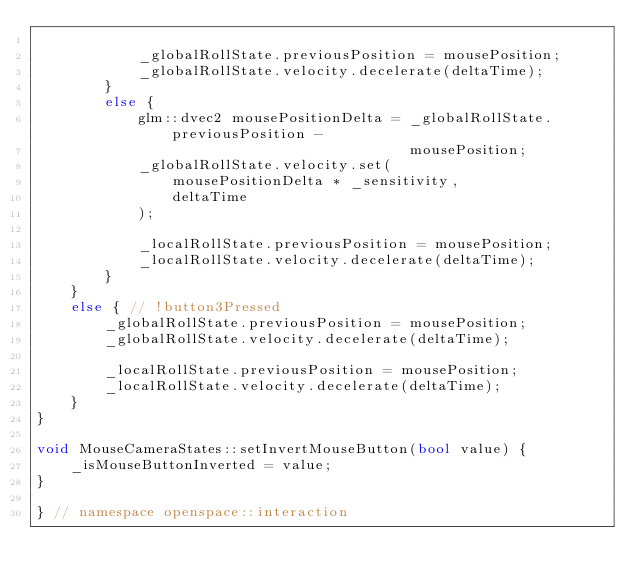Convert code to text. <code><loc_0><loc_0><loc_500><loc_500><_C++_>
            _globalRollState.previousPosition = mousePosition;
            _globalRollState.velocity.decelerate(deltaTime);
        }
        else {
            glm::dvec2 mousePositionDelta = _globalRollState.previousPosition -
                                            mousePosition;
            _globalRollState.velocity.set(
                mousePositionDelta * _sensitivity,
                deltaTime
            );

            _localRollState.previousPosition = mousePosition;
            _localRollState.velocity.decelerate(deltaTime);
        }
    }
    else { // !button3Pressed
        _globalRollState.previousPosition = mousePosition;
        _globalRollState.velocity.decelerate(deltaTime);

        _localRollState.previousPosition = mousePosition;
        _localRollState.velocity.decelerate(deltaTime);
    }
}

void MouseCameraStates::setInvertMouseButton(bool value) {
    _isMouseButtonInverted = value;
}

} // namespace openspace::interaction
</code> 